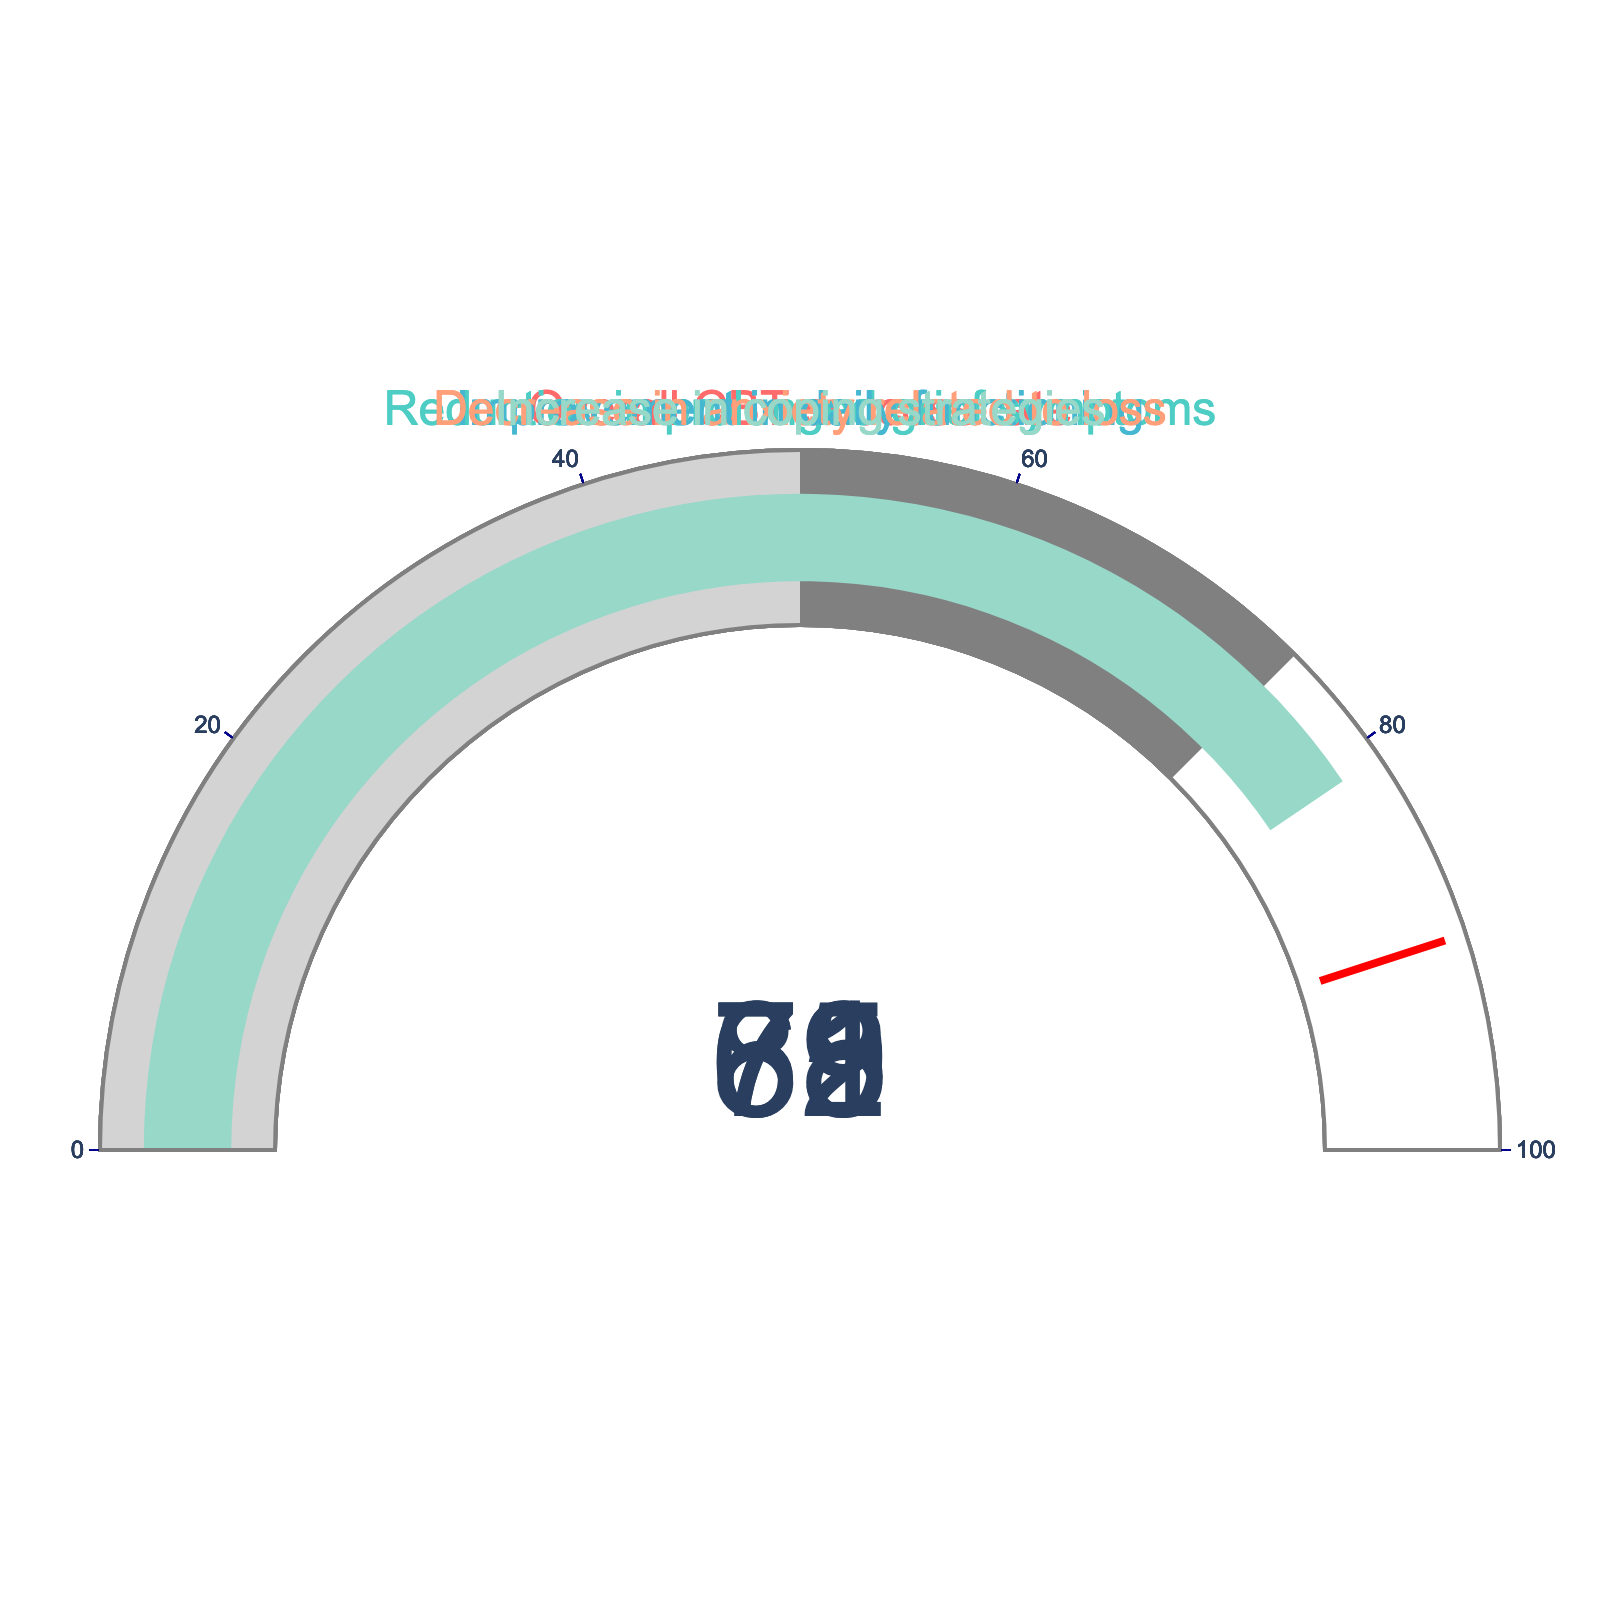What is the overall CBT success rate according to the figure? The gauge for "Overall CBT success rate" shows a value of 78.
Answer: 78 Which effectiveness rate is the highest among the metrics shown? The gauge showing "Increase in coping strategies" has the highest value, which is 81.
Answer: Increase in coping strategies How much higher is the "Increase in coping strategies" rate compared to the "Overall CBT success rate"? The "Increase in coping strategies" is 81, and the "Overall CBT success rate" is 78. The difference is 81 - 78 = 3.
Answer: 3 What is the median value of all the different effectiveness rates shown in the figure? The values given are 78, 65, 72, 69, and 81. Arranging them in order: 65, 69, 72, 78, 81, the middle value or median is 72.
Answer: 72 Which measure shows the lowest effectiveness rate? The gauge for "Reduction in prolonged grief symptoms" shows the lowest value, which is 65.
Answer: Reduction in prolonged grief symptoms Is the "Improvement in daily functioning" rate greater than the "Decrease in anxiety related to loss" rate? The gauge for "Improvement in daily functioning" has a value of 72, while the gauge for "Decrease in anxiety related to loss" has a value of 69. Since 72 is greater than 69, the answer is yes.
Answer: Yes What is the average effectiveness rate across all the measures shown? The values are 78, 65, 72, 69, and 81. The sum is 78 + 65 + 72 + 69 + 81 = 365. Dividing by 5 gives 365 / 5 = 73.
Answer: 73 Between the "Reduction in prolonged grief symptoms" and "Decrease in anxiety related to loss," which has a higher effectiveness rate? The gauge for "Reduction in prolonged grief symptoms" is 65, and the gauge for "Decrease in anxiety related to loss" is 69. Since 69 is higher than 65, the "Decrease in anxiety related to loss" has a higher rate.
Answer: Decrease in anxiety related to loss 